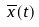Convert formula to latex. <formula><loc_0><loc_0><loc_500><loc_500>\overline { x } ( t )</formula> 